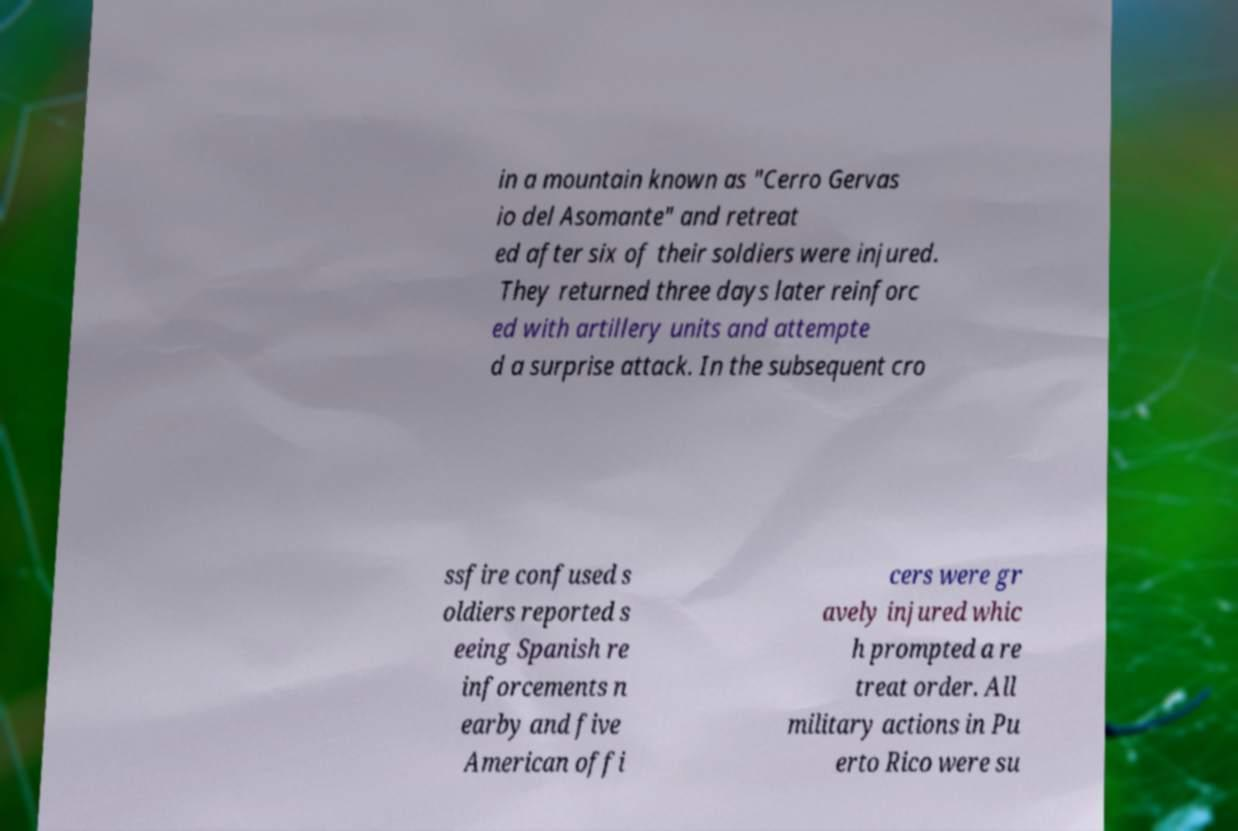There's text embedded in this image that I need extracted. Can you transcribe it verbatim? in a mountain known as "Cerro Gervas io del Asomante" and retreat ed after six of their soldiers were injured. They returned three days later reinforc ed with artillery units and attempte d a surprise attack. In the subsequent cro ssfire confused s oldiers reported s eeing Spanish re inforcements n earby and five American offi cers were gr avely injured whic h prompted a re treat order. All military actions in Pu erto Rico were su 